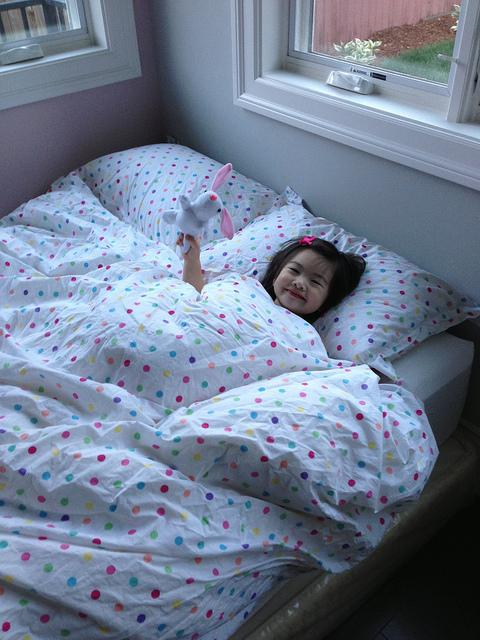Who is in the bed?

Choices:
A) mom
B) rabbit
C) little girl
D) man little girl 